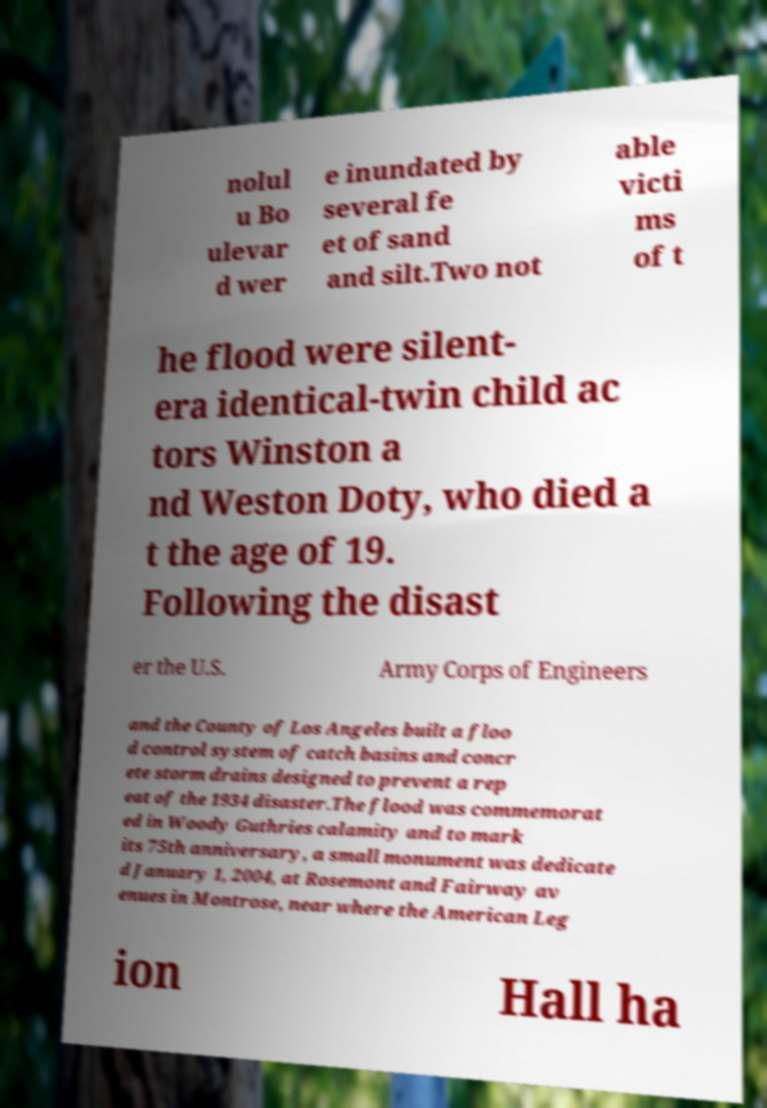Can you accurately transcribe the text from the provided image for me? nolul u Bo ulevar d wer e inundated by several fe et of sand and silt.Two not able victi ms of t he flood were silent- era identical-twin child ac tors Winston a nd Weston Doty, who died a t the age of 19. Following the disast er the U.S. Army Corps of Engineers and the County of Los Angeles built a floo d control system of catch basins and concr ete storm drains designed to prevent a rep eat of the 1934 disaster.The flood was commemorat ed in Woody Guthries calamity and to mark its 75th anniversary, a small monument was dedicate d January 1, 2004, at Rosemont and Fairway av enues in Montrose, near where the American Leg ion Hall ha 